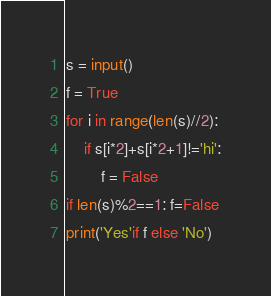Convert code to text. <code><loc_0><loc_0><loc_500><loc_500><_Python_>s = input()
f = True
for i in range(len(s)//2):
    if s[i*2]+s[i*2+1]!='hi':
        f = False
if len(s)%2==1: f=False
print('Yes'if f else 'No')</code> 